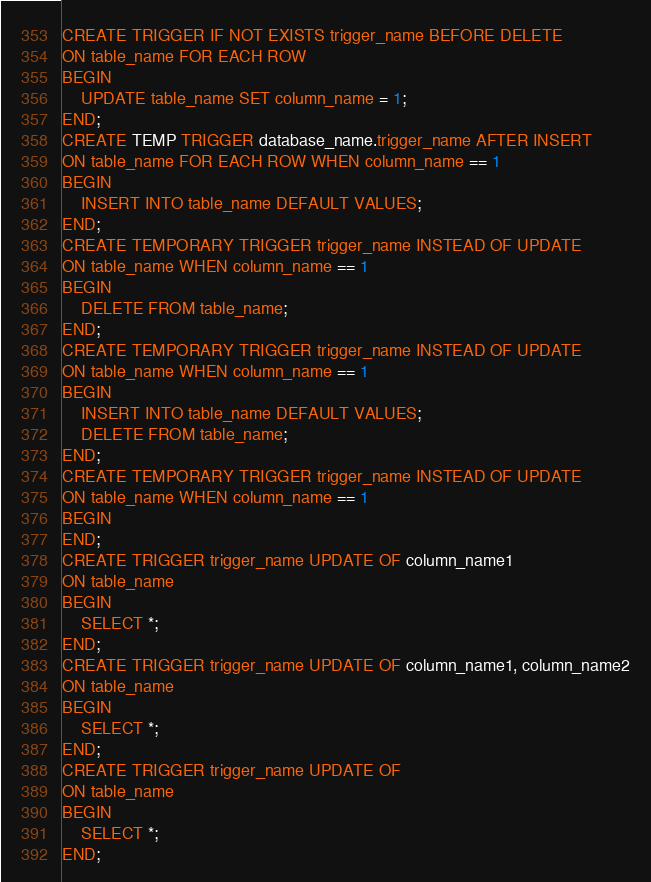Convert code to text. <code><loc_0><loc_0><loc_500><loc_500><_SQL_>CREATE TRIGGER IF NOT EXISTS trigger_name BEFORE DELETE
ON table_name FOR EACH ROW
BEGIN
    UPDATE table_name SET column_name = 1; 
END;
CREATE TEMP TRIGGER database_name.trigger_name AFTER INSERT
ON table_name FOR EACH ROW WHEN column_name == 1
BEGIN
    INSERT INTO table_name DEFAULT VALUES; 
END;
CREATE TEMPORARY TRIGGER trigger_name INSTEAD OF UPDATE
ON table_name WHEN column_name == 1
BEGIN
    DELETE FROM table_name; 
END;
CREATE TEMPORARY TRIGGER trigger_name INSTEAD OF UPDATE
ON table_name WHEN column_name == 1
BEGIN
    INSERT INTO table_name DEFAULT VALUES; 
    DELETE FROM table_name; 
END;
CREATE TEMPORARY TRIGGER trigger_name INSTEAD OF UPDATE
ON table_name WHEN column_name == 1
BEGIN
END;
CREATE TRIGGER trigger_name UPDATE OF column_name1
ON table_name
BEGIN
    SELECT *; 
END;
CREATE TRIGGER trigger_name UPDATE OF column_name1, column_name2
ON table_name
BEGIN
    SELECT *; 
END;
CREATE TRIGGER trigger_name UPDATE OF
ON table_name
BEGIN
    SELECT *; 
END;</code> 